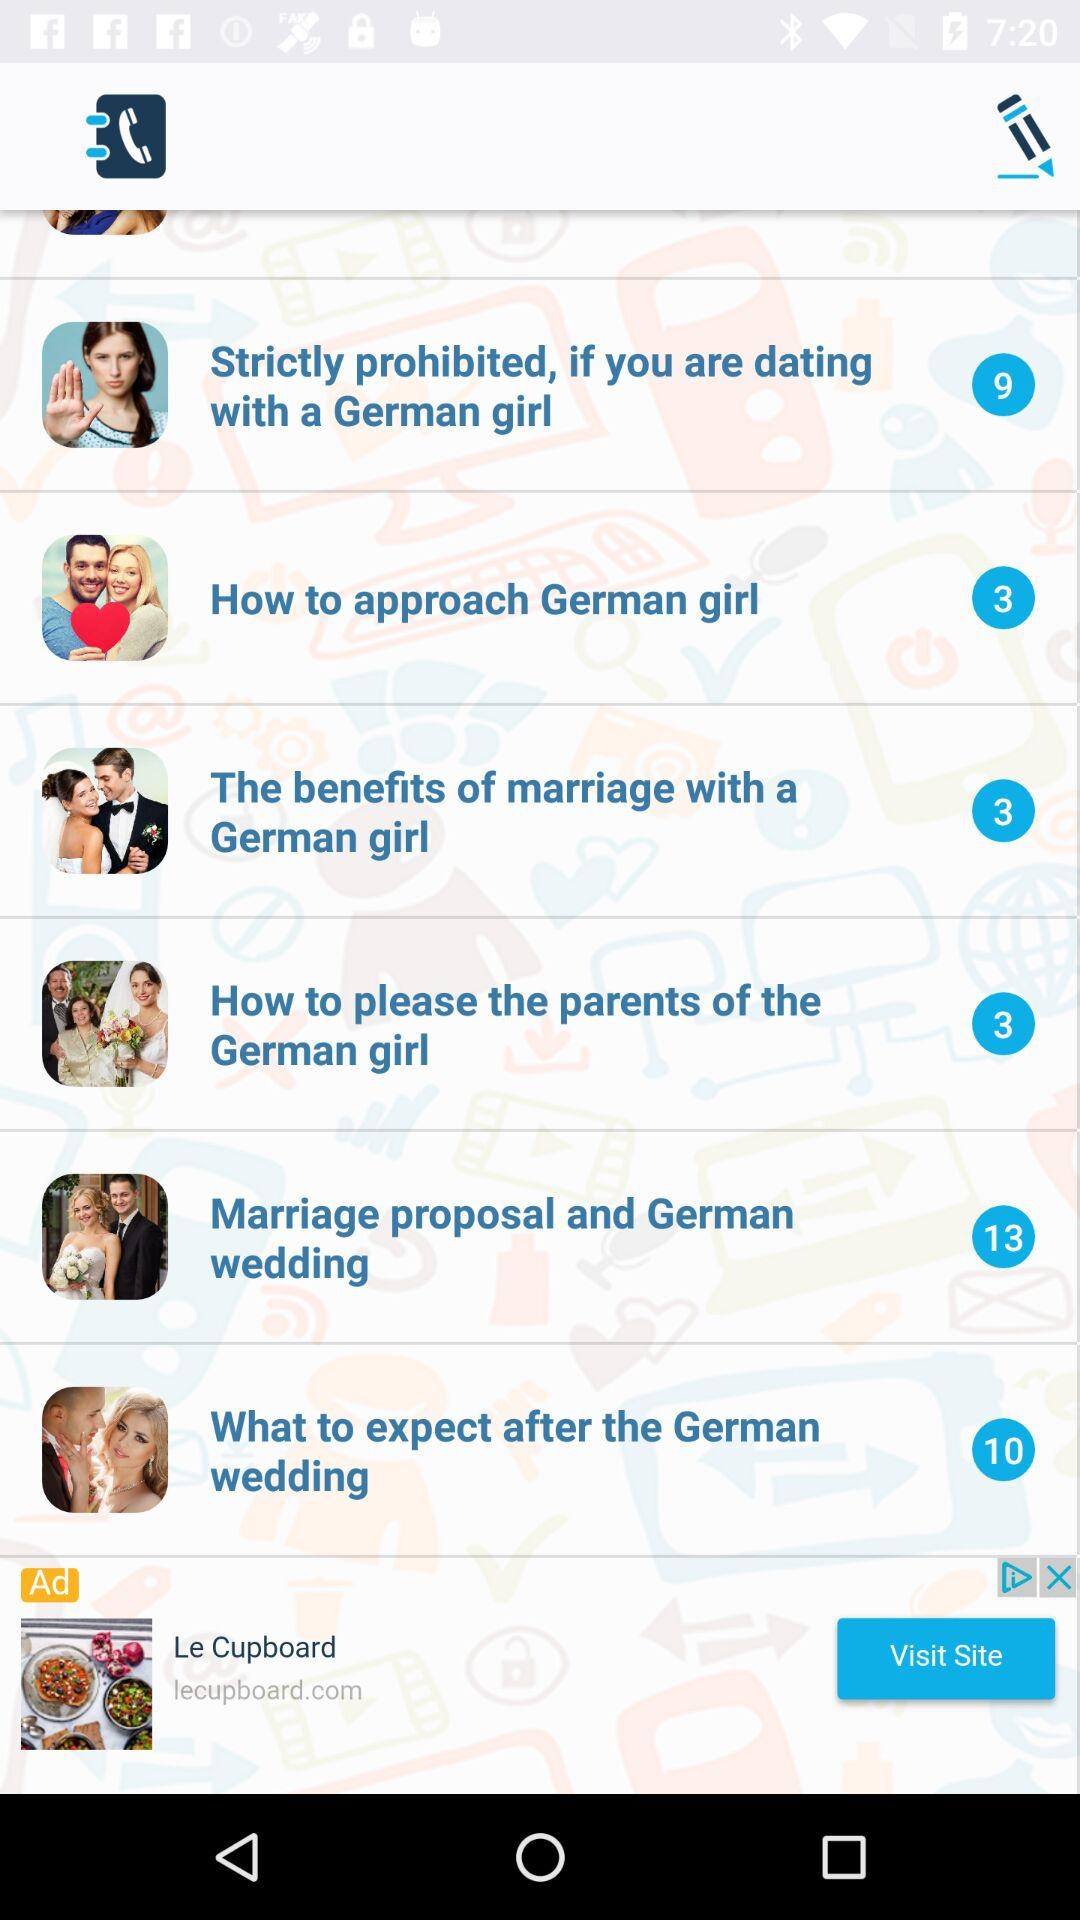How many tips are there for marriage proposals and German weddings? There are 13 tips for marriage proposals and German weddings. 